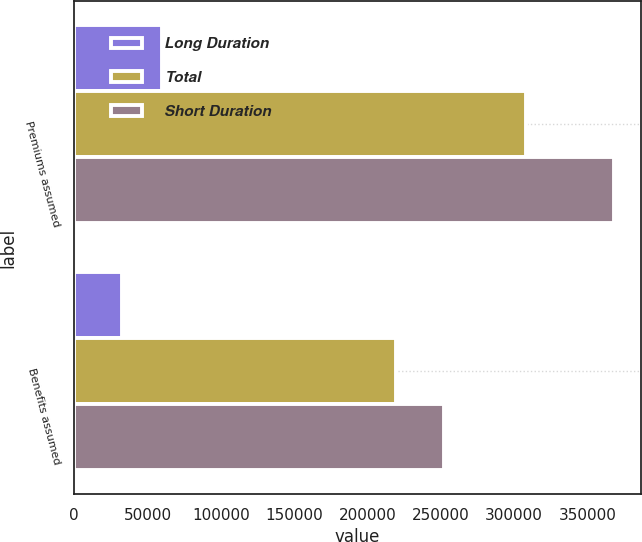Convert chart. <chart><loc_0><loc_0><loc_500><loc_500><stacked_bar_chart><ecel><fcel>Premiums assumed<fcel>Benefits assumed<nl><fcel>Long Duration<fcel>59706<fcel>32494<nl><fcel>Total<fcel>308432<fcel>219665<nl><fcel>Short Duration<fcel>368138<fcel>252159<nl></chart> 